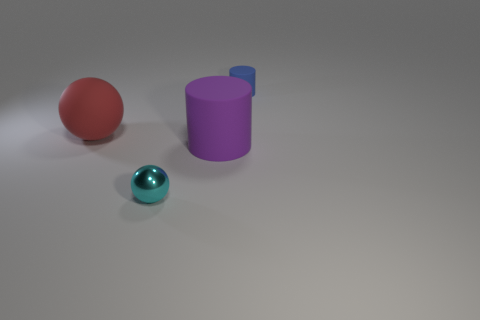What might be the function of the small blue sphere? The small blue sphere, with its glossy finish and vibrant hue, might serve as a decorative element or could represent an object used in educational settings to illustrate concepts like geometry or color theory. Its size and simplicity suggest it is not intended for complex functions. 